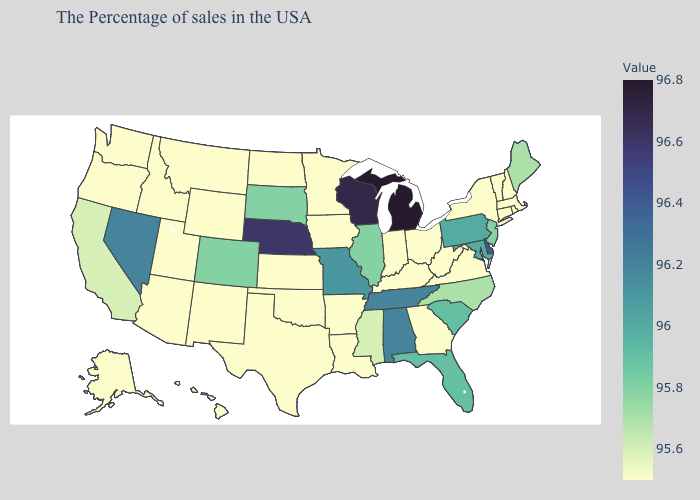Does the map have missing data?
Keep it brief. No. Is the legend a continuous bar?
Give a very brief answer. Yes. Which states have the lowest value in the USA?
Keep it brief. Massachusetts, Rhode Island, New Hampshire, Vermont, Connecticut, New York, Virginia, West Virginia, Ohio, Georgia, Kentucky, Indiana, Louisiana, Arkansas, Minnesota, Iowa, Kansas, Oklahoma, Texas, North Dakota, Wyoming, New Mexico, Utah, Montana, Arizona, Idaho, Washington, Oregon, Alaska, Hawaii. Does California have the lowest value in the West?
Quick response, please. No. Does the map have missing data?
Give a very brief answer. No. 